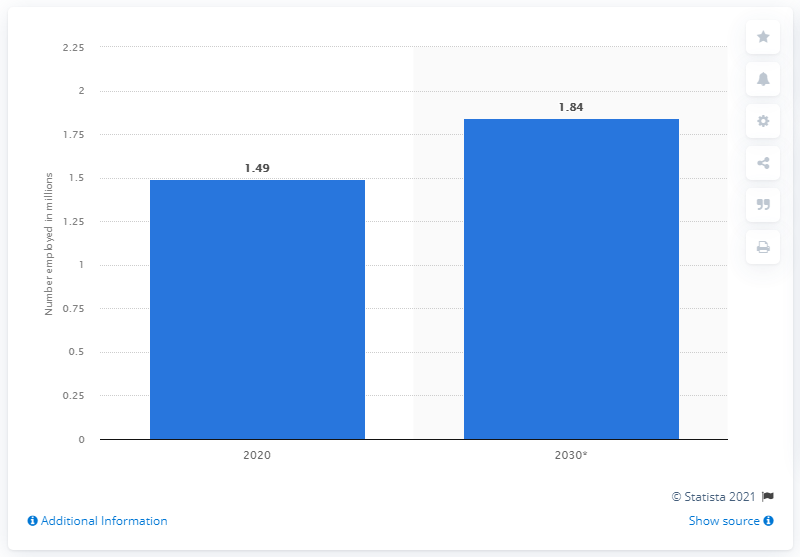Outline some significant characteristics in this image. By 2030, it is projected that approximately 1.84 million software developers and quality assurance workers will be employed in the United States. In 2020, approximately 1.49 million software developers and software quality assurance workers were employed in the United States. 